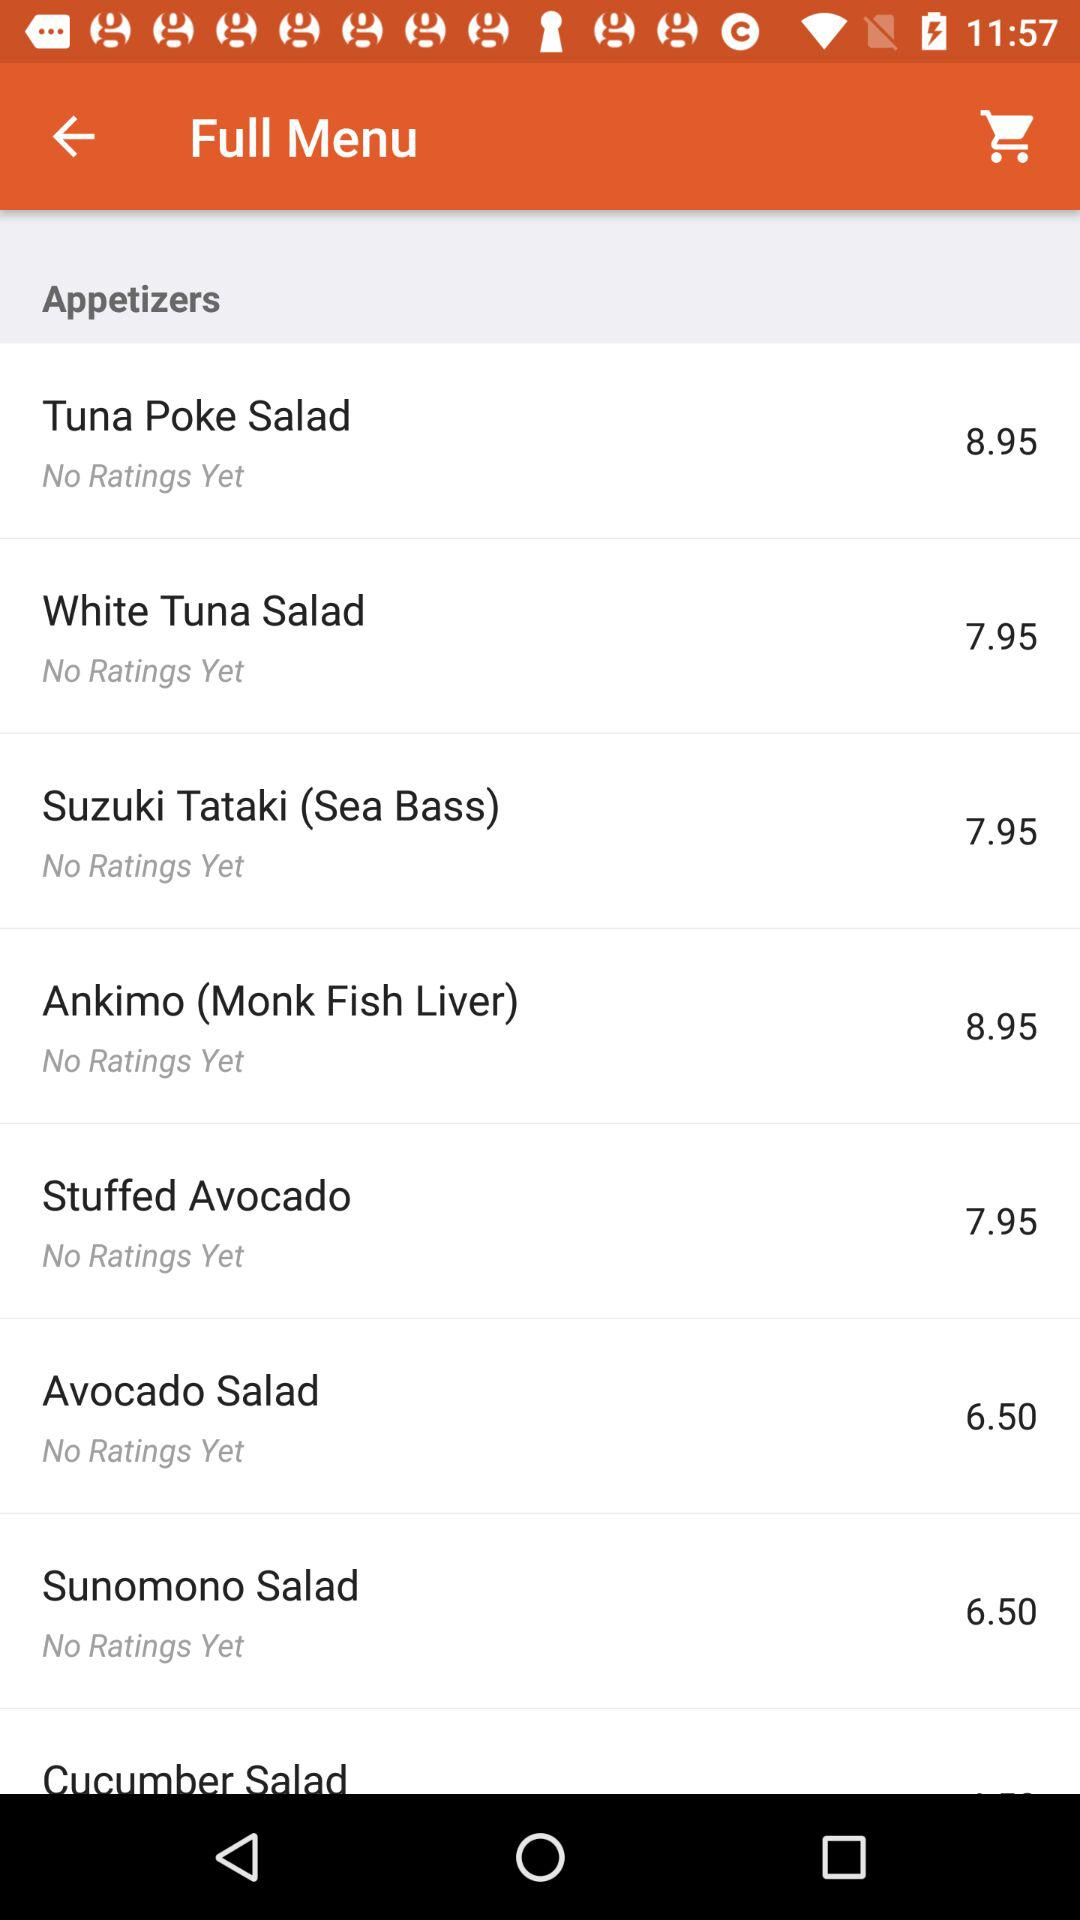How much more does the price of the White Tuna Salad cost than the Avocado Salad?
Answer the question using a single word or phrase. 1.45 